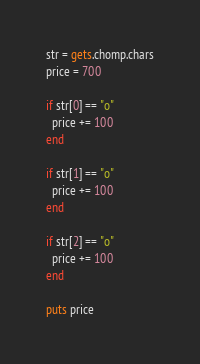Convert code to text. <code><loc_0><loc_0><loc_500><loc_500><_Ruby_>str = gets.chomp.chars
price = 700

if str[0] == "o"
  price += 100
end

if str[1] == "o"
  price += 100
end

if str[2] == "o"
  price += 100
end

puts price</code> 